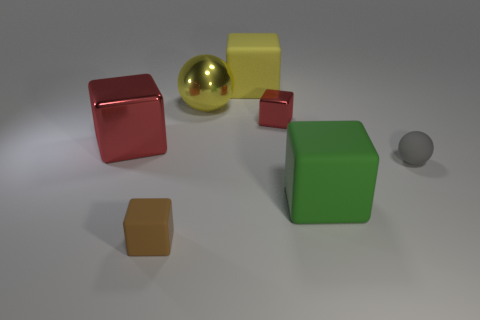Subtract all small cubes. How many cubes are left? 3 Subtract all yellow cubes. How many cubes are left? 4 Subtract all spheres. How many objects are left? 5 Subtract all large rubber things. Subtract all tiny rubber spheres. How many objects are left? 4 Add 4 brown things. How many brown things are left? 5 Add 5 brown objects. How many brown objects exist? 6 Add 2 tiny brown matte objects. How many objects exist? 9 Subtract 0 yellow cylinders. How many objects are left? 7 Subtract 1 blocks. How many blocks are left? 4 Subtract all yellow spheres. Subtract all yellow cubes. How many spheres are left? 1 